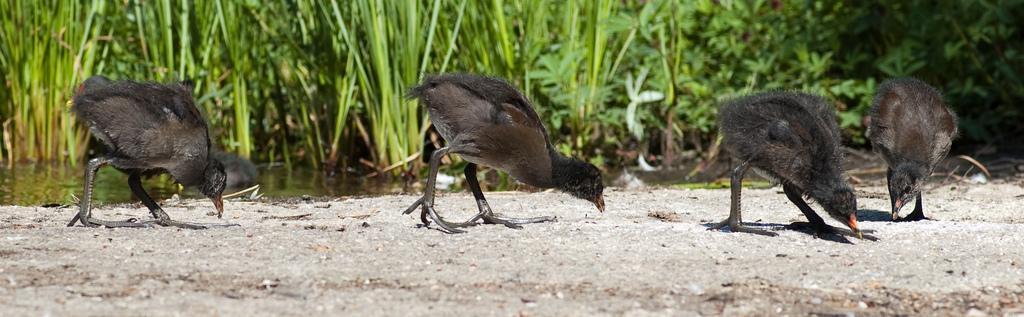Describe this image in one or two sentences. In the picture we can see a mud surface on it, we can see some birds are walking and eating something on the surface and the birds are black in color with some part gray in color and behind it we can see water with grass plants in it. 